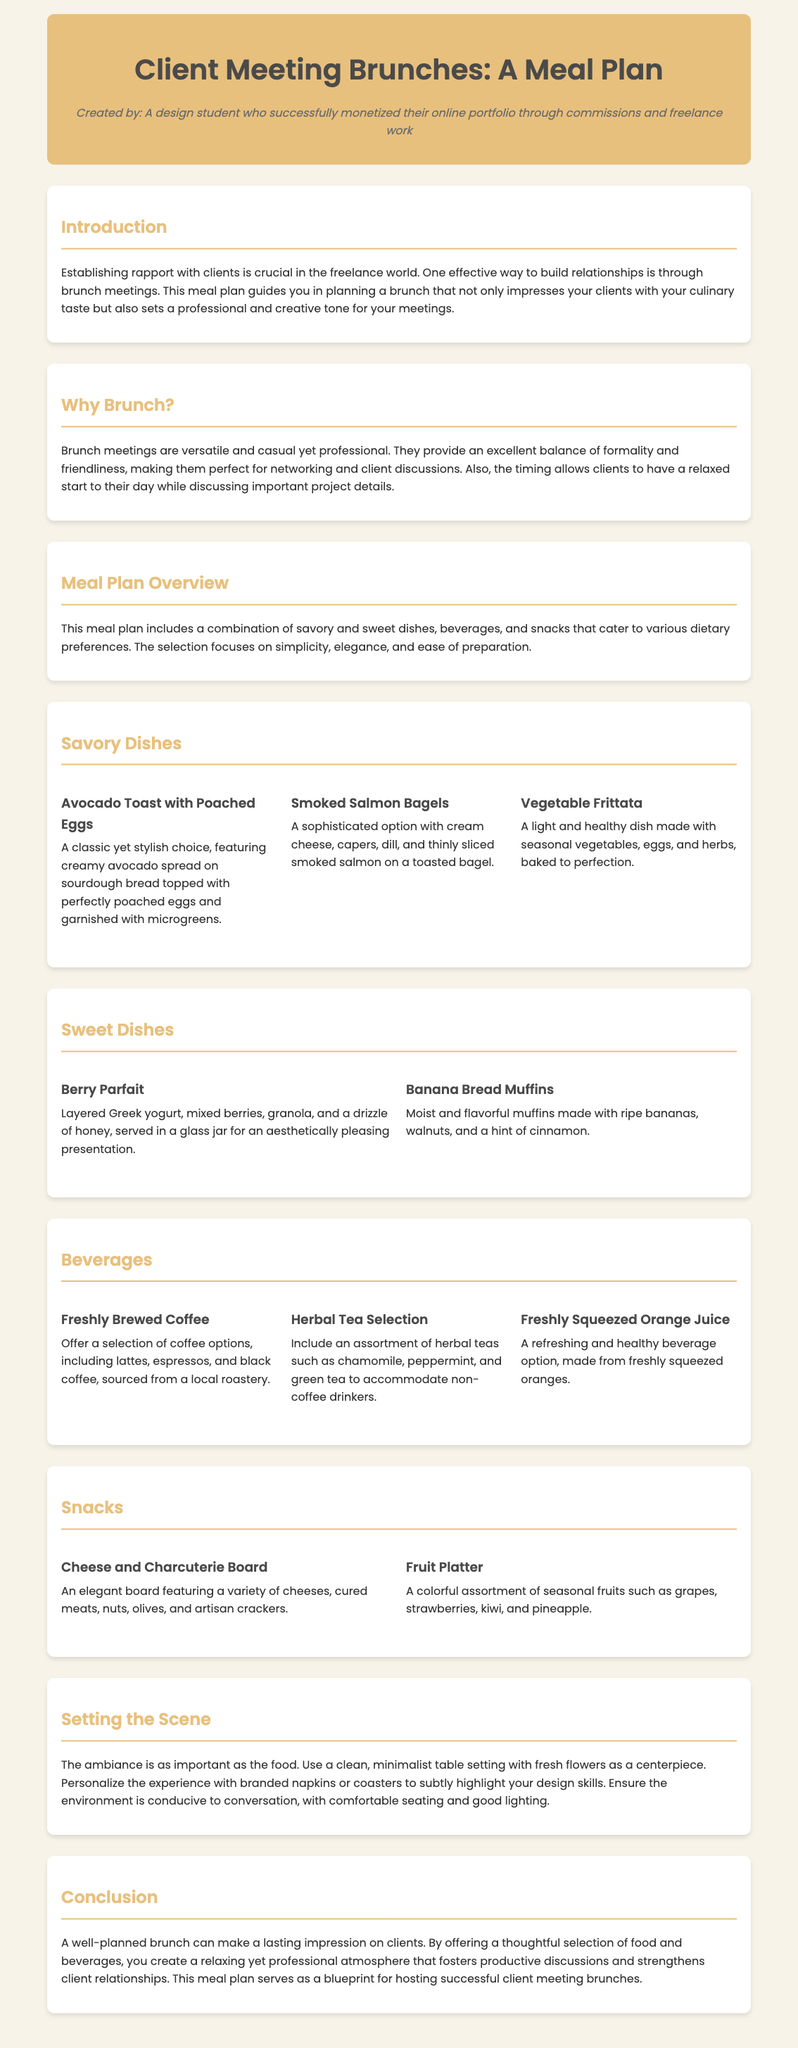What is the title of the document? The title is prominently displayed at the top of the document, which is "Client Meeting Brunches: A Meal Plan".
Answer: Client Meeting Brunches: A Meal Plan What type of student created this meal plan? The document states that it was created by a "design student who successfully monetized their online portfolio through commissions and freelance work".
Answer: Design student What is one savory dish mentioned in the meal plan? The section for savory dishes lists options such as "Avocado Toast with Poached Eggs".
Answer: Avocado Toast with Poached Eggs What beverage option is included for non-coffee drinkers? The document includes a selection of herbal teas such as "chamomile, peppermint, and green tea".
Answer: Herbal Tea Selection How many sweet dishes are listed in the document? There are two sweet dishes highlighted in the meal plan section.
Answer: Two What is suggested to be in the center of the table setting? The document mentions using "fresh flowers" as a centerpiece for the table setting.
Answer: Fresh flowers Why are brunch meetings considered ideal? The document explains that brunch meetings provide an excellent balance of "formality and friendliness".
Answer: Formality and friendliness What should the environment be conducive to? The document suggests the environment should be conducive to "conversation".
Answer: Conversation What type of board is suggested as a snack option? The meal plan mentions a "Cheese and Charcuterie Board" as one of the snack options.
Answer: Cheese and Charcuterie Board 